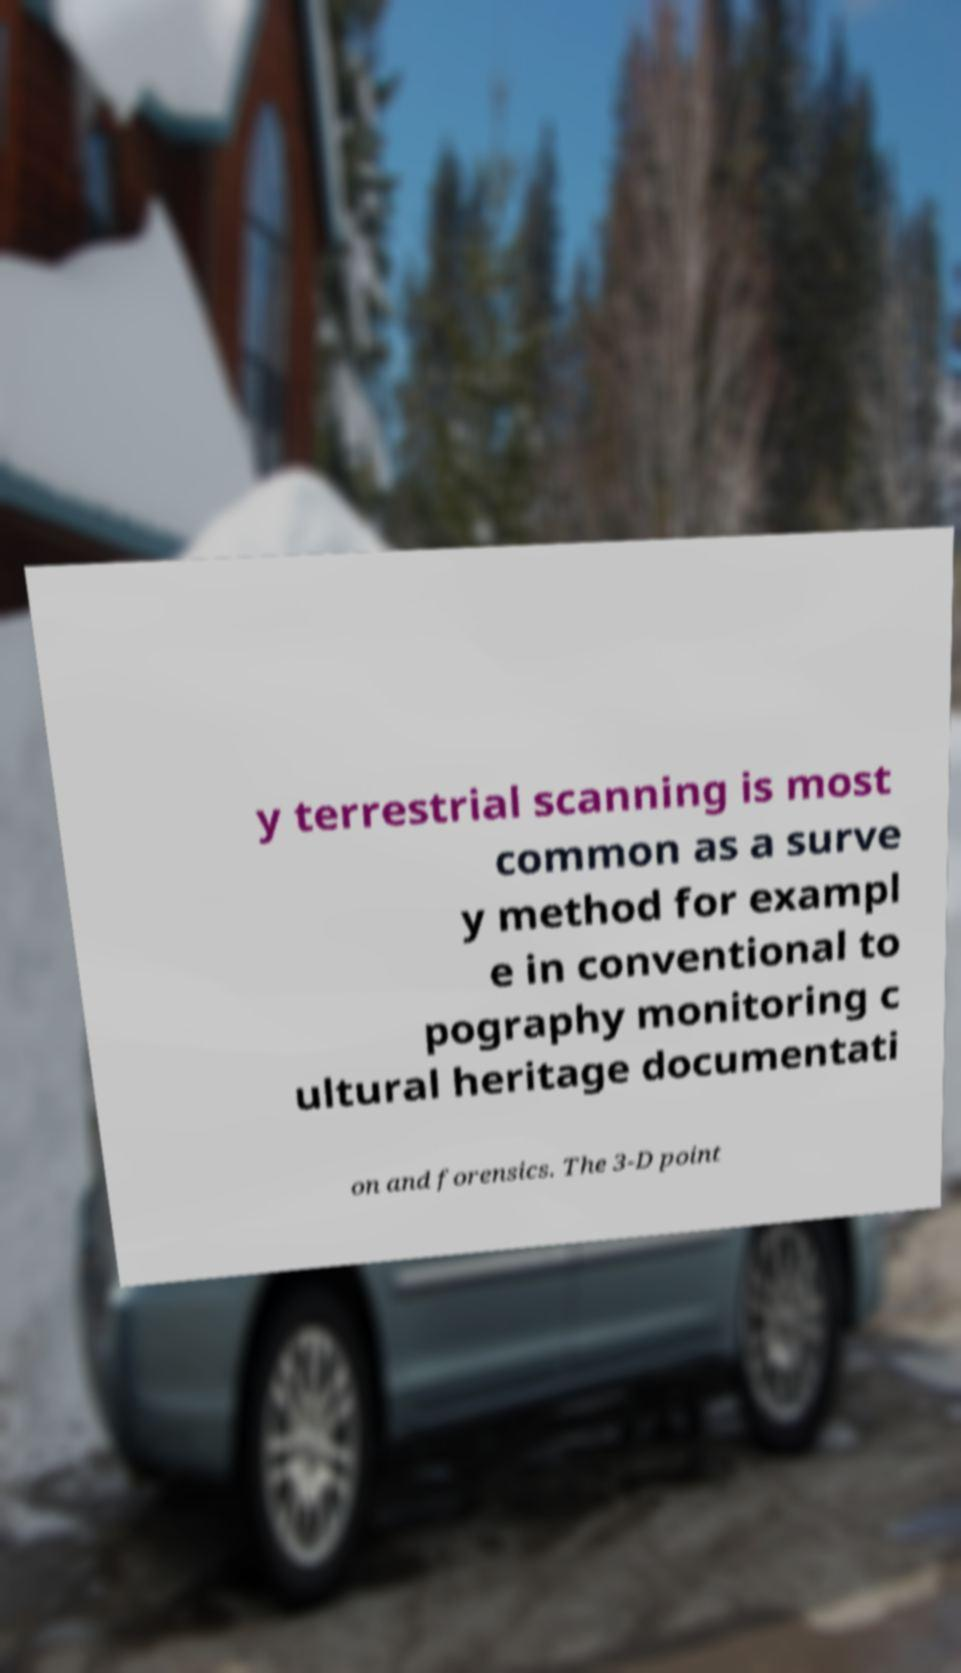Please identify and transcribe the text found in this image. y terrestrial scanning is most common as a surve y method for exampl e in conventional to pography monitoring c ultural heritage documentati on and forensics. The 3-D point 